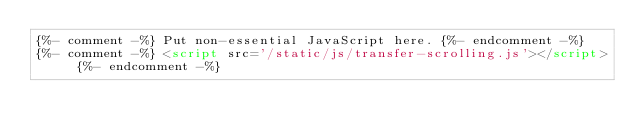Convert code to text. <code><loc_0><loc_0><loc_500><loc_500><_HTML_>{%- comment -%} Put non-essential JavaScript here. {%- endcomment -%}
{%- comment -%} <script src='/static/js/transfer-scrolling.js'></script> {%- endcomment -%}
</code> 